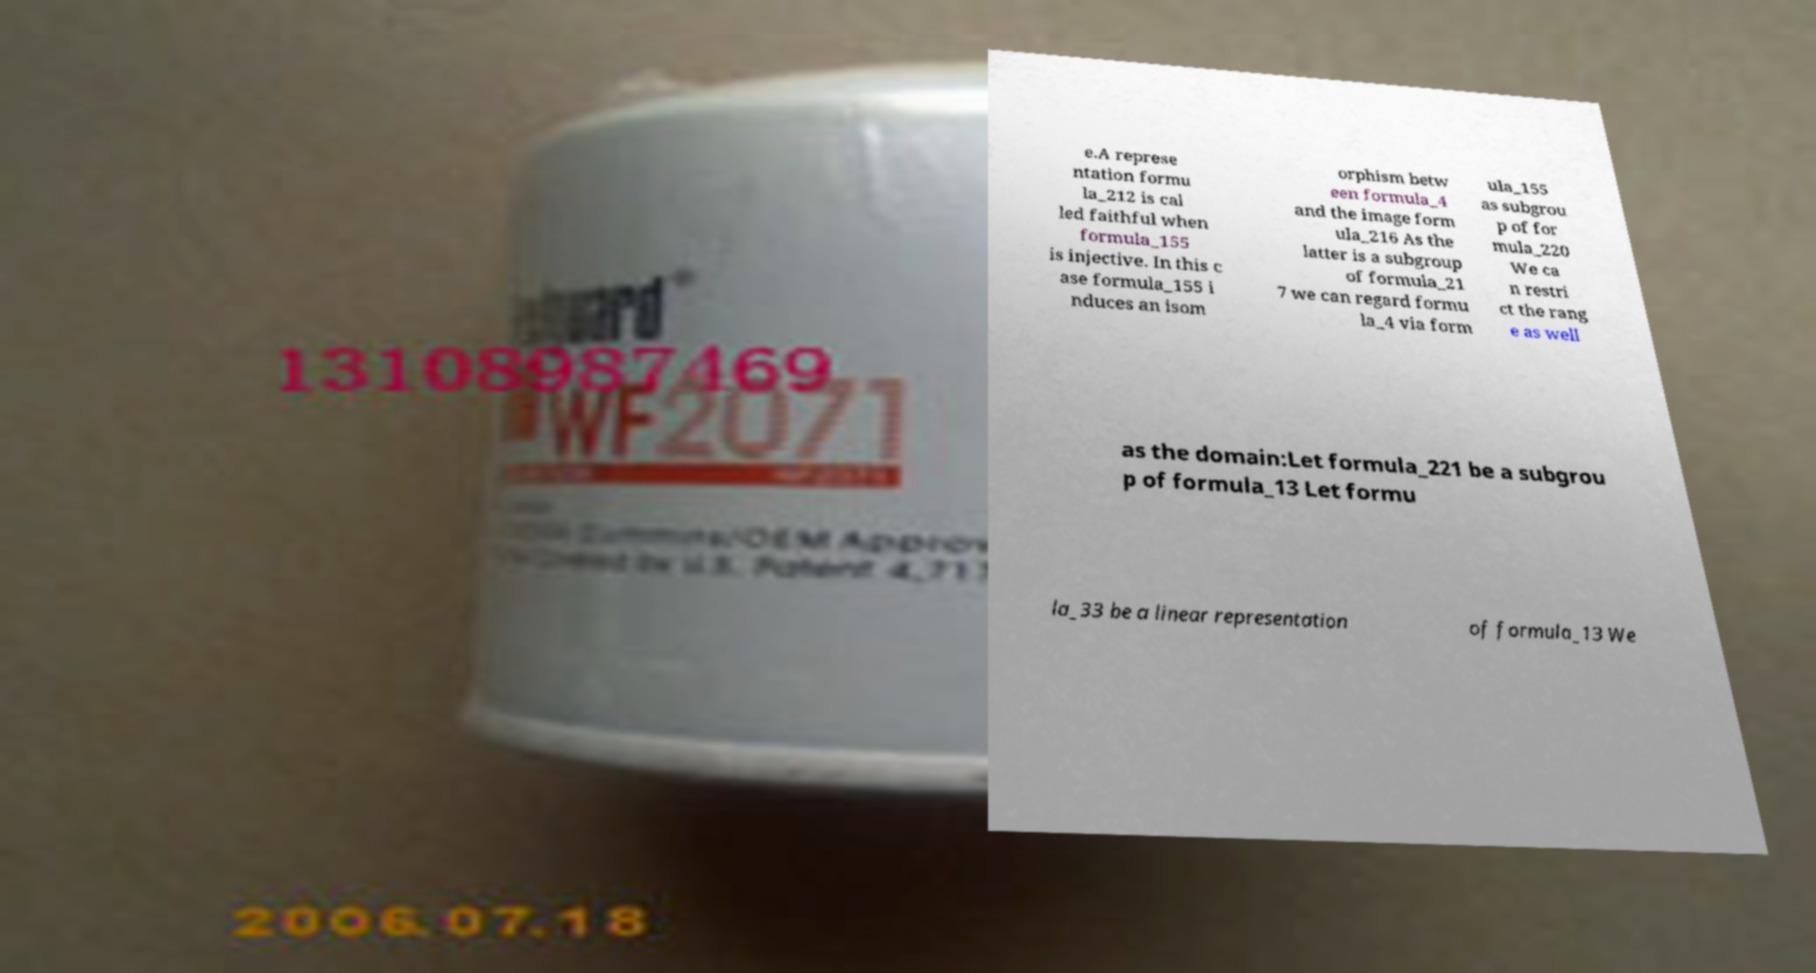Please read and relay the text visible in this image. What does it say? e.A represe ntation formu la_212 is cal led faithful when formula_155 is injective. In this c ase formula_155 i nduces an isom orphism betw een formula_4 and the image form ula_216 As the latter is a subgroup of formula_21 7 we can regard formu la_4 via form ula_155 as subgrou p of for mula_220 We ca n restri ct the rang e as well as the domain:Let formula_221 be a subgrou p of formula_13 Let formu la_33 be a linear representation of formula_13 We 